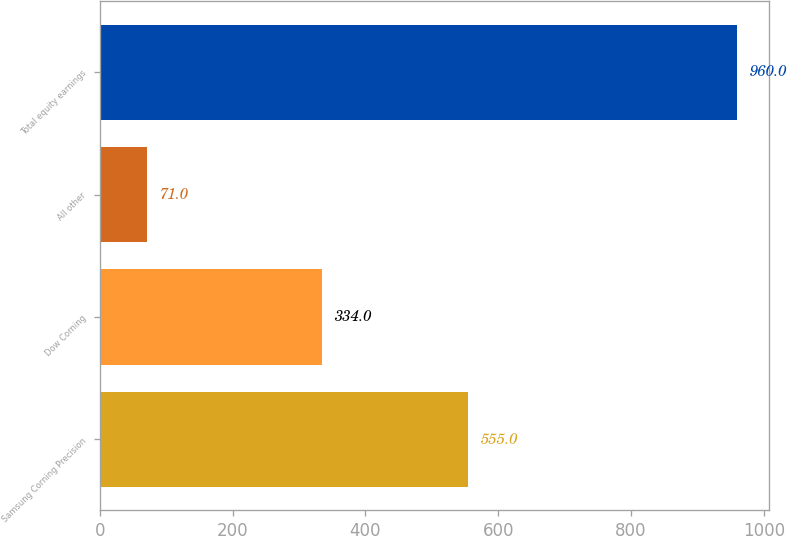<chart> <loc_0><loc_0><loc_500><loc_500><bar_chart><fcel>Samsung Corning Precision<fcel>Dow Corning<fcel>All other<fcel>Total equity earnings<nl><fcel>555<fcel>334<fcel>71<fcel>960<nl></chart> 